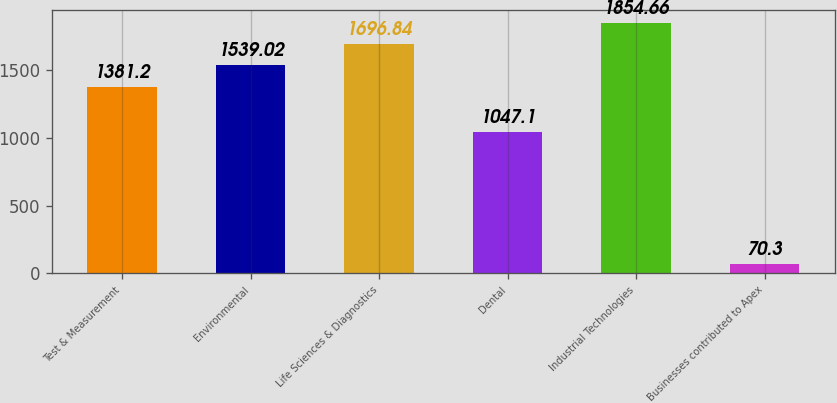Convert chart. <chart><loc_0><loc_0><loc_500><loc_500><bar_chart><fcel>Test & Measurement<fcel>Environmental<fcel>Life Sciences & Diagnostics<fcel>Dental<fcel>Industrial Technologies<fcel>Businesses contributed to Apex<nl><fcel>1381.2<fcel>1539.02<fcel>1696.84<fcel>1047.1<fcel>1854.66<fcel>70.3<nl></chart> 